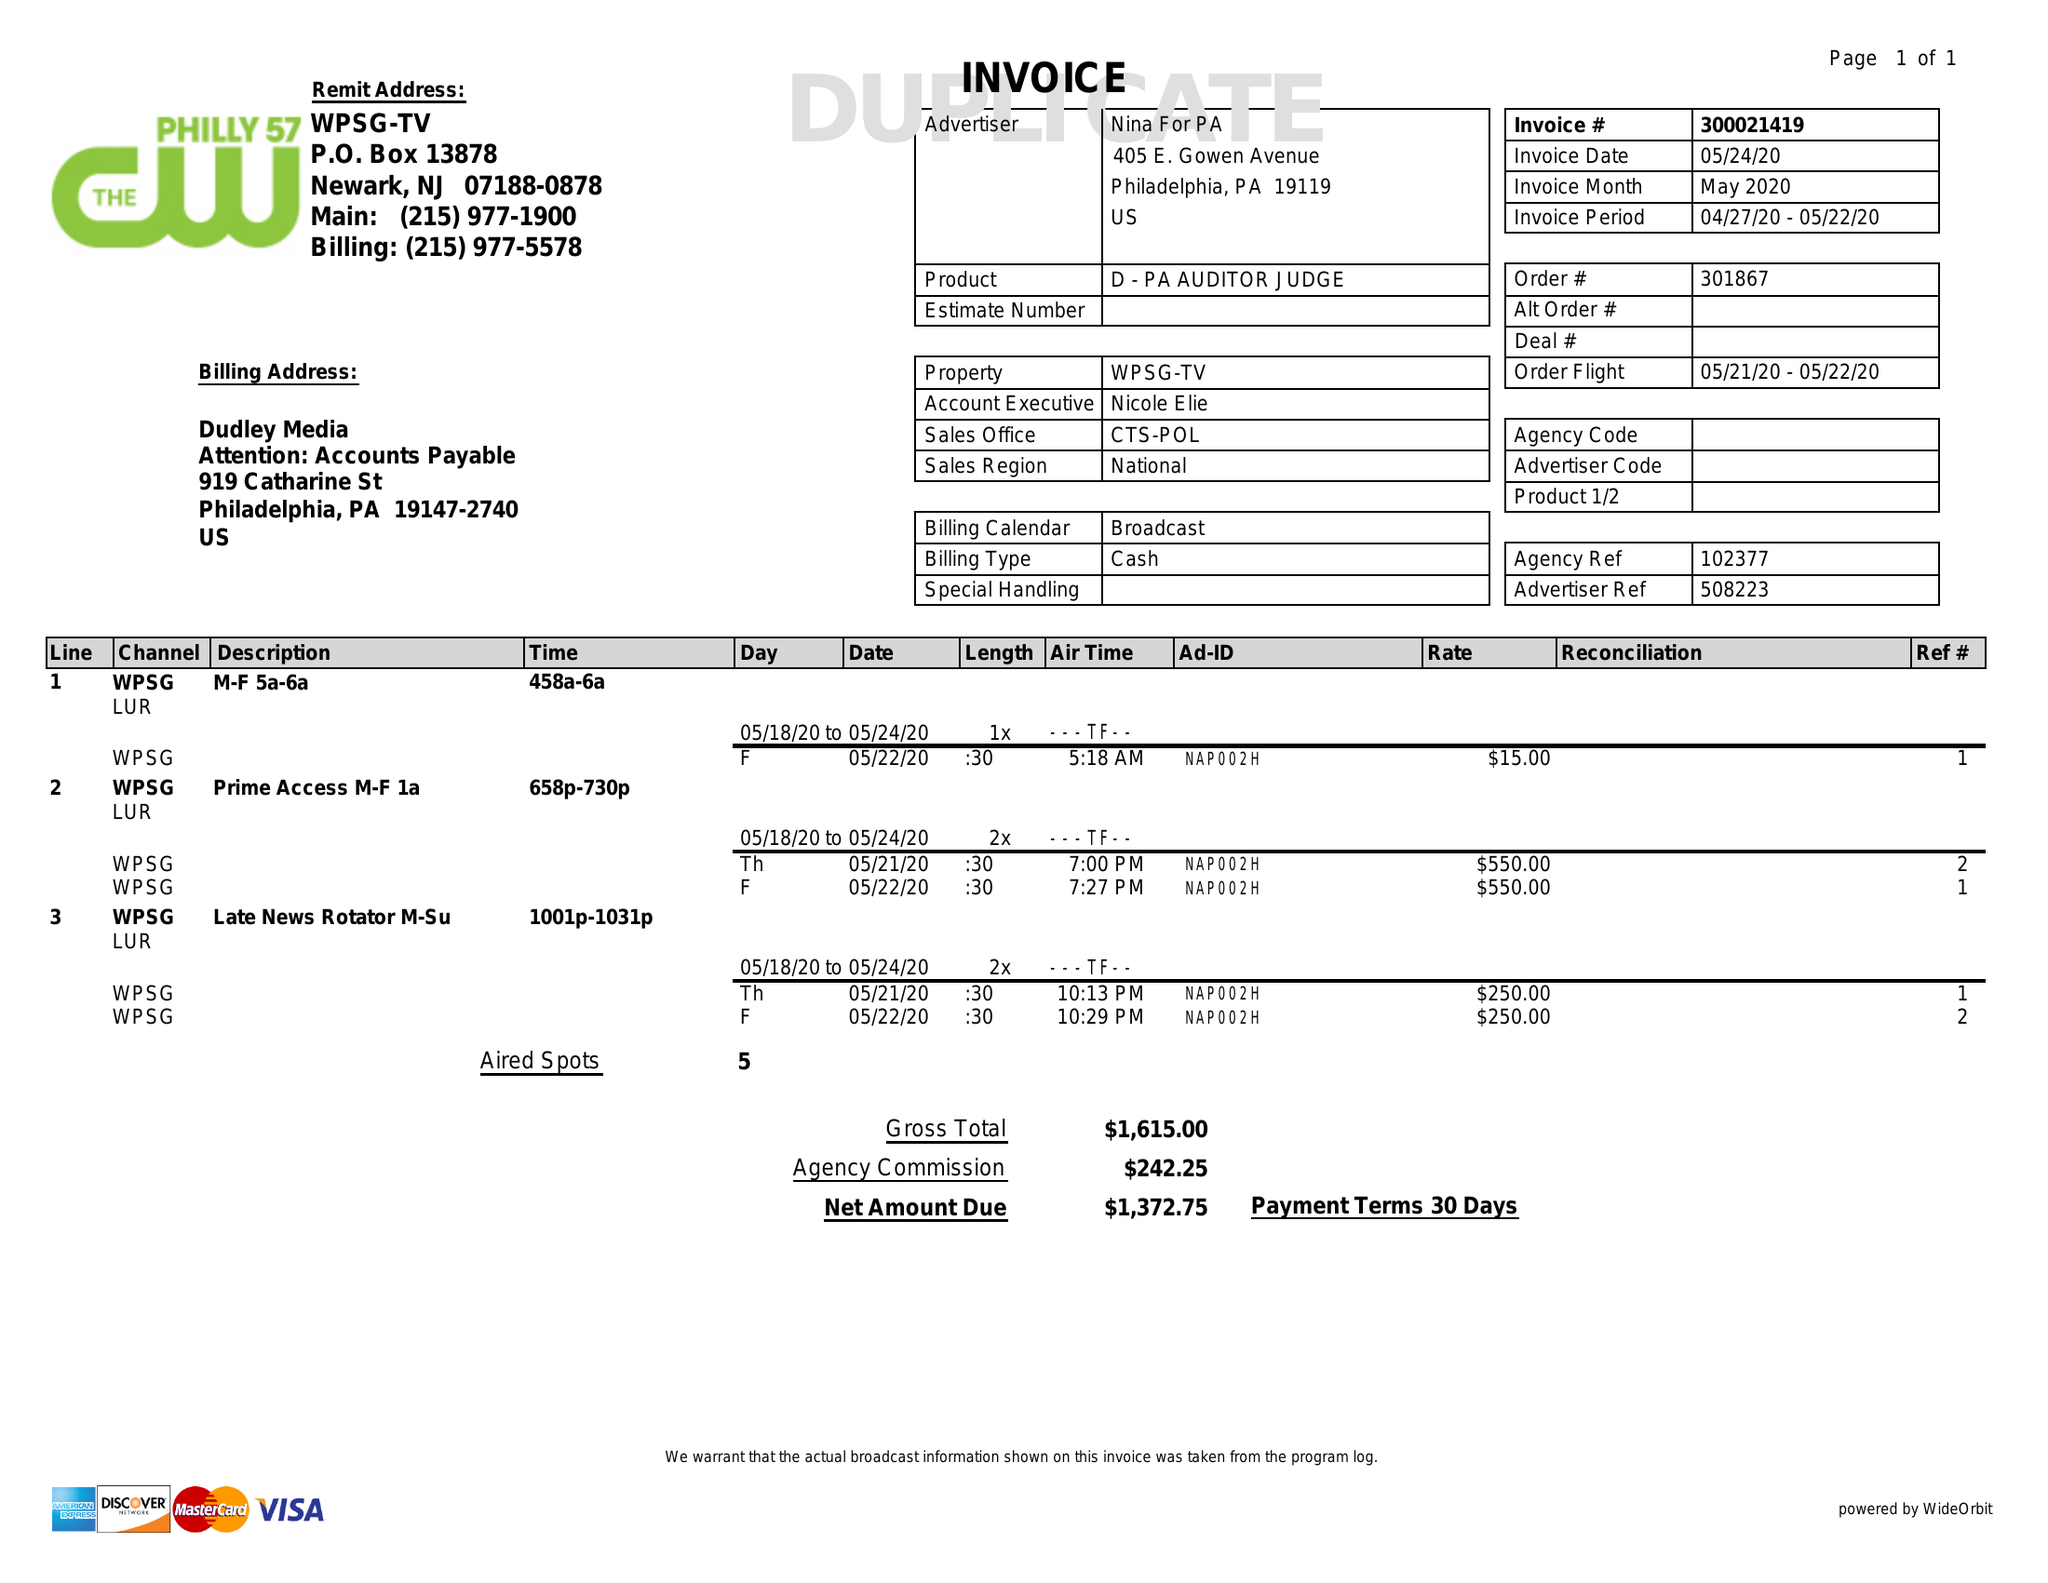What is the value for the flight_from?
Answer the question using a single word or phrase. 05/21/20 